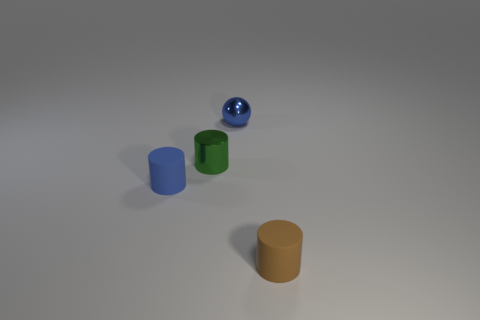There is a small brown cylinder; what number of tiny green objects are right of it?
Provide a short and direct response. 0. How many cubes are either small green objects or small blue shiny objects?
Make the answer very short. 0. There is a cylinder that is both on the left side of the brown matte cylinder and on the right side of the tiny blue cylinder; what is its size?
Ensure brevity in your answer.  Small. How many other things are the same color as the metal ball?
Provide a succinct answer. 1. Is the tiny brown object made of the same material as the blue object that is behind the green cylinder?
Your answer should be very brief. No. What number of things are small cylinders that are behind the tiny brown rubber cylinder or small matte objects?
Offer a terse response. 3. What shape is the object that is to the right of the green shiny cylinder and behind the small blue cylinder?
Provide a short and direct response. Sphere. Is there any other thing that has the same size as the blue shiny thing?
Keep it short and to the point. Yes. What size is the blue thing that is made of the same material as the tiny green thing?
Offer a very short reply. Small. How many objects are matte things behind the brown object or blue objects behind the green cylinder?
Offer a very short reply. 2. 